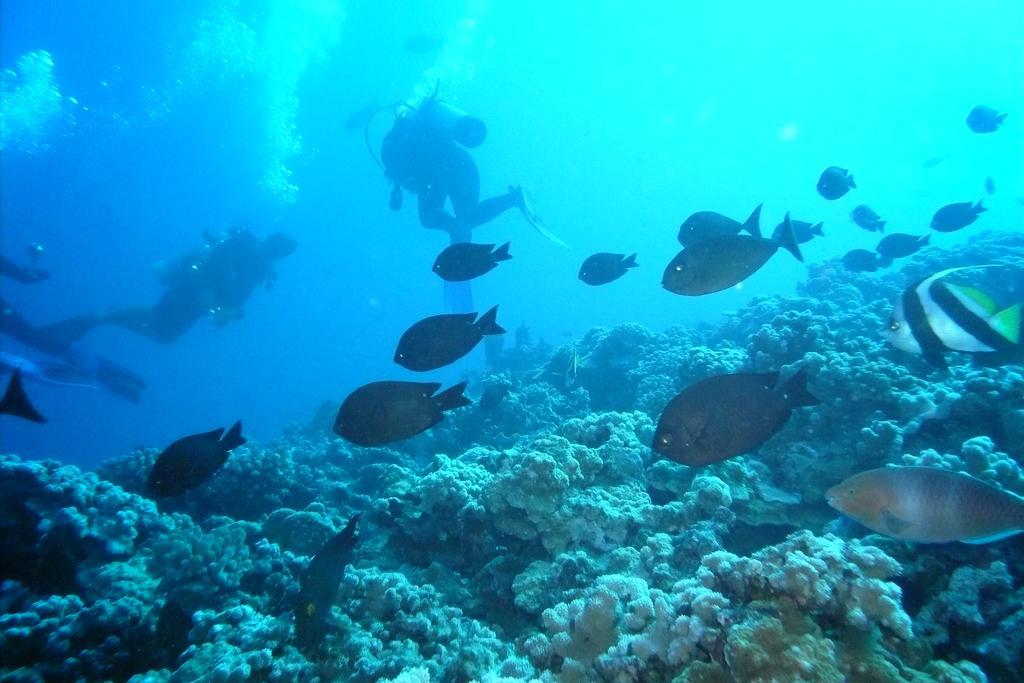Describe this image in one or two sentences. In this picture there are three persons under the water and there are few fishes and some other objects in front of them. 